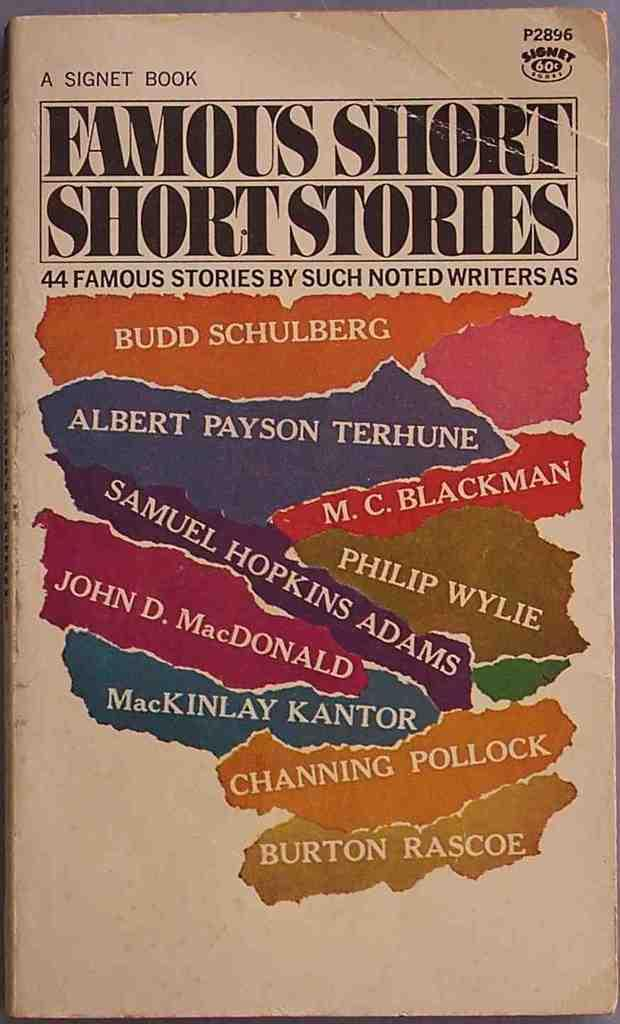Provide a one-sentence caption for the provided image. A book of Famous Short Short Stories by many noted authors. 